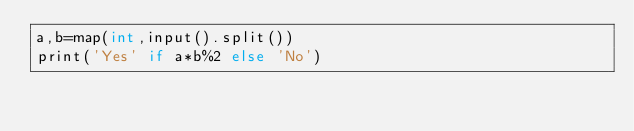<code> <loc_0><loc_0><loc_500><loc_500><_C++_>a,b=map(int,input().split())
print('Yes' if a*b%2 else 'No')</code> 